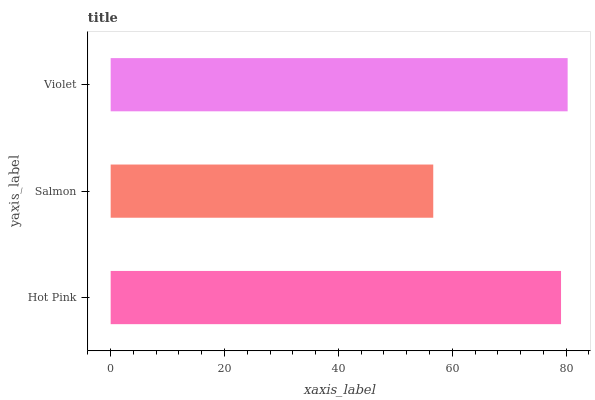Is Salmon the minimum?
Answer yes or no. Yes. Is Violet the maximum?
Answer yes or no. Yes. Is Violet the minimum?
Answer yes or no. No. Is Salmon the maximum?
Answer yes or no. No. Is Violet greater than Salmon?
Answer yes or no. Yes. Is Salmon less than Violet?
Answer yes or no. Yes. Is Salmon greater than Violet?
Answer yes or no. No. Is Violet less than Salmon?
Answer yes or no. No. Is Hot Pink the high median?
Answer yes or no. Yes. Is Hot Pink the low median?
Answer yes or no. Yes. Is Violet the high median?
Answer yes or no. No. Is Violet the low median?
Answer yes or no. No. 